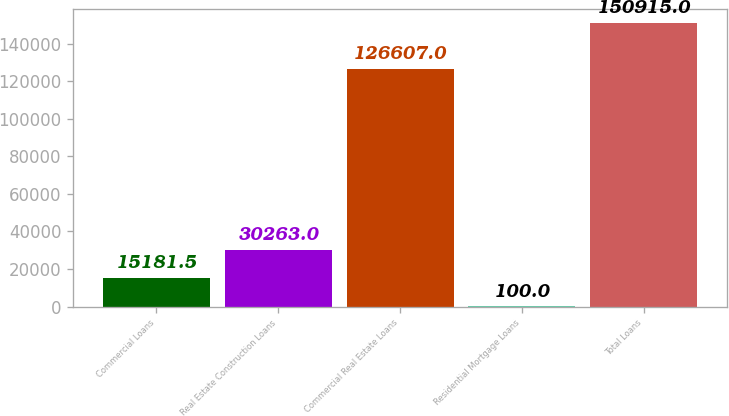Convert chart. <chart><loc_0><loc_0><loc_500><loc_500><bar_chart><fcel>Commercial Loans<fcel>Real Estate Construction Loans<fcel>Commercial Real Estate Loans<fcel>Residential Mortgage Loans<fcel>Total Loans<nl><fcel>15181.5<fcel>30263<fcel>126607<fcel>100<fcel>150915<nl></chart> 